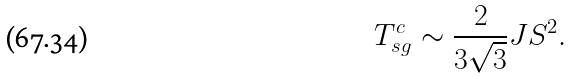Convert formula to latex. <formula><loc_0><loc_0><loc_500><loc_500>T ^ { c } _ { s g } \sim \frac { 2 } { 3 \sqrt { 3 } } J S ^ { 2 } .</formula> 